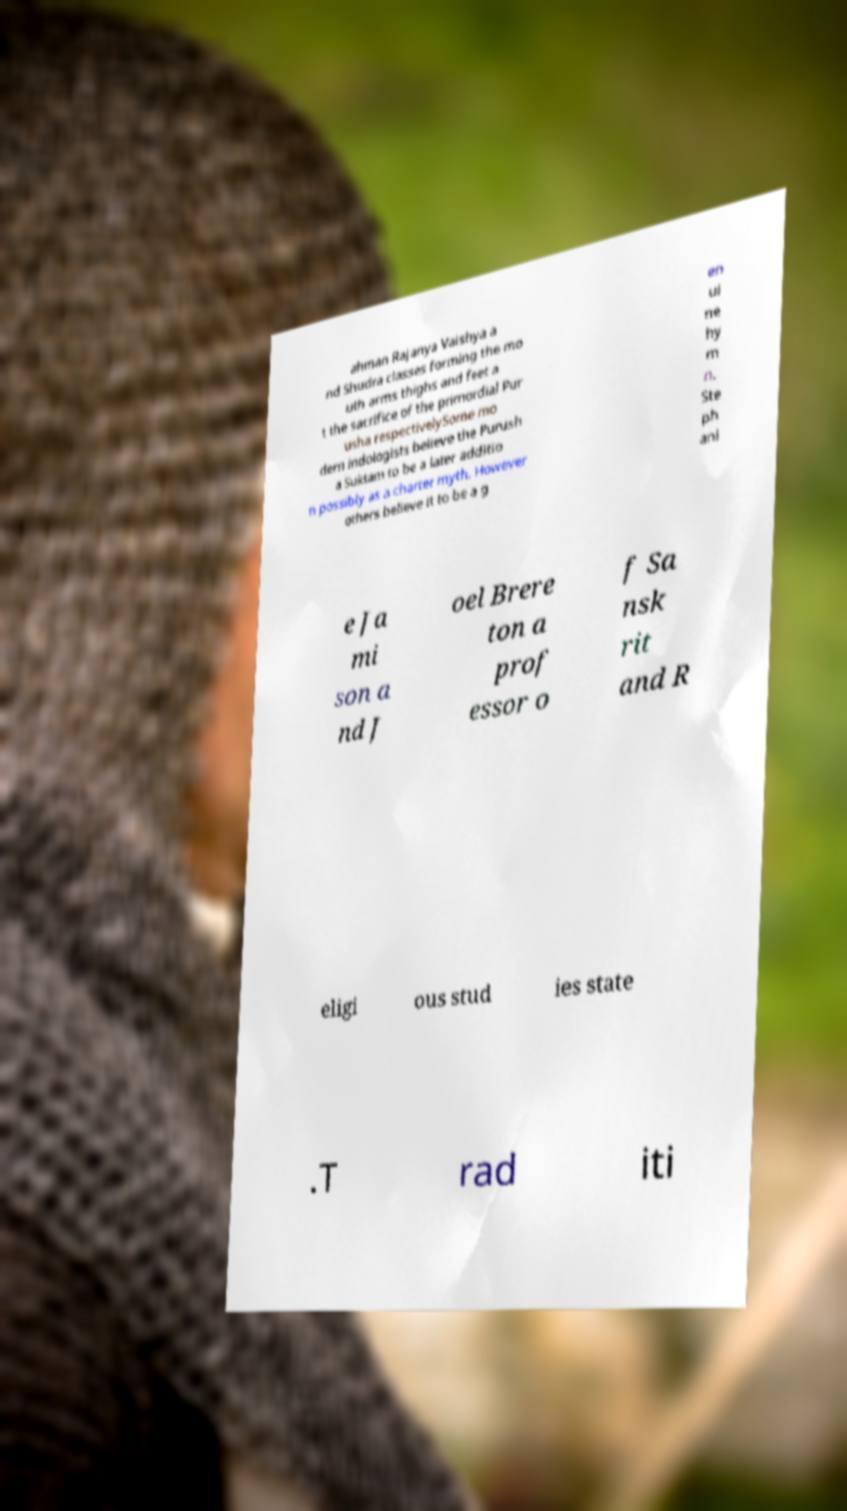For documentation purposes, I need the text within this image transcribed. Could you provide that? ahman Rajanya Vaishya a nd Shudra classes forming the mo uth arms thighs and feet a t the sacrifice of the primordial Pur usha respectivelySome mo dern indologists believe the Purush a Suktam to be a later additio n possibly as a charter myth. However others believe it to be a g en ui ne hy m n. Ste ph ani e Ja mi son a nd J oel Brere ton a prof essor o f Sa nsk rit and R eligi ous stud ies state .T rad iti 